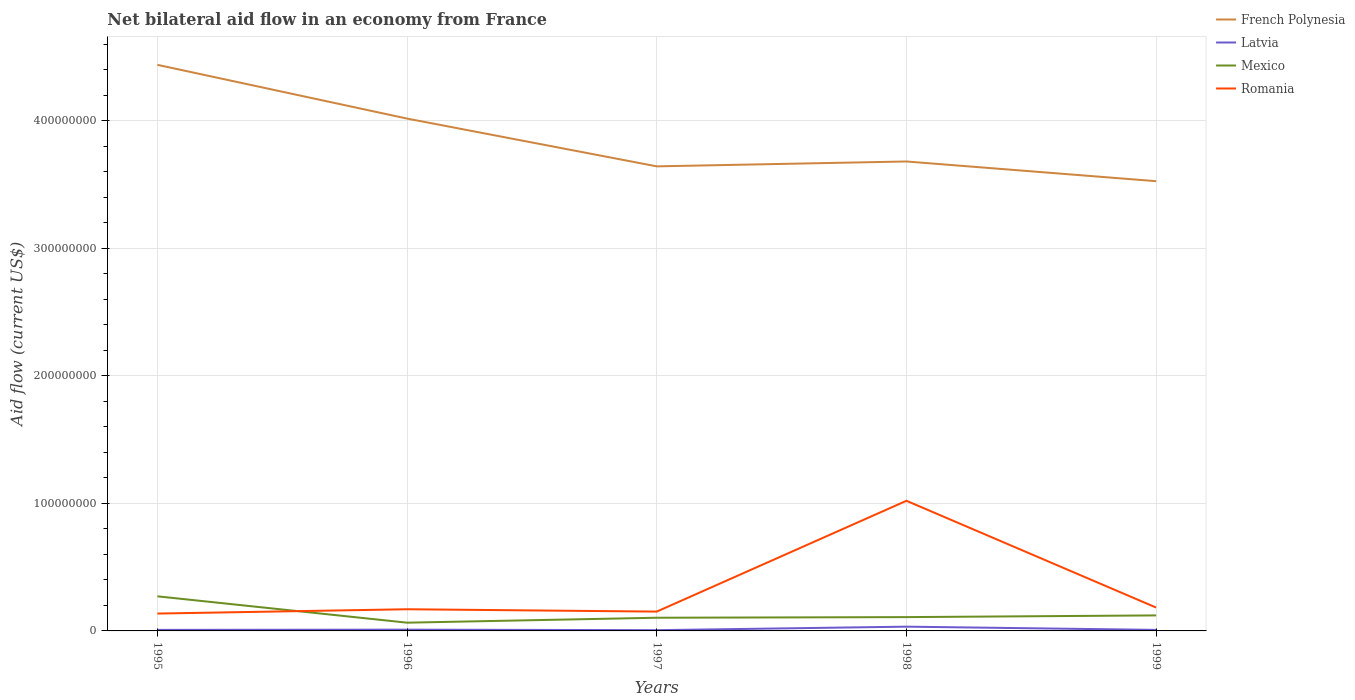How many different coloured lines are there?
Keep it short and to the point. 4. Across all years, what is the maximum net bilateral aid flow in Romania?
Offer a terse response. 1.36e+07. What is the total net bilateral aid flow in Latvia in the graph?
Provide a short and direct response. -2.52e+06. What is the difference between the highest and the second highest net bilateral aid flow in Mexico?
Give a very brief answer. 2.07e+07. What is the difference between the highest and the lowest net bilateral aid flow in Mexico?
Make the answer very short. 1. How many lines are there?
Provide a short and direct response. 4. What is the difference between two consecutive major ticks on the Y-axis?
Offer a terse response. 1.00e+08. Are the values on the major ticks of Y-axis written in scientific E-notation?
Keep it short and to the point. No. Does the graph contain grids?
Your answer should be compact. Yes. Where does the legend appear in the graph?
Keep it short and to the point. Top right. How many legend labels are there?
Your response must be concise. 4. How are the legend labels stacked?
Offer a terse response. Vertical. What is the title of the graph?
Ensure brevity in your answer.  Net bilateral aid flow in an economy from France. Does "Canada" appear as one of the legend labels in the graph?
Ensure brevity in your answer.  No. What is the Aid flow (current US$) of French Polynesia in 1995?
Your answer should be compact. 4.44e+08. What is the Aid flow (current US$) in Latvia in 1995?
Provide a succinct answer. 8.20e+05. What is the Aid flow (current US$) in Mexico in 1995?
Ensure brevity in your answer.  2.71e+07. What is the Aid flow (current US$) of Romania in 1995?
Keep it short and to the point. 1.36e+07. What is the Aid flow (current US$) in French Polynesia in 1996?
Keep it short and to the point. 4.02e+08. What is the Aid flow (current US$) in Latvia in 1996?
Offer a very short reply. 1.00e+06. What is the Aid flow (current US$) of Mexico in 1996?
Your response must be concise. 6.47e+06. What is the Aid flow (current US$) of Romania in 1996?
Offer a terse response. 1.70e+07. What is the Aid flow (current US$) in French Polynesia in 1997?
Your answer should be compact. 3.64e+08. What is the Aid flow (current US$) in Latvia in 1997?
Ensure brevity in your answer.  5.90e+05. What is the Aid flow (current US$) of Mexico in 1997?
Provide a succinct answer. 1.03e+07. What is the Aid flow (current US$) of Romania in 1997?
Offer a very short reply. 1.52e+07. What is the Aid flow (current US$) in French Polynesia in 1998?
Keep it short and to the point. 3.68e+08. What is the Aid flow (current US$) of Latvia in 1998?
Your answer should be very brief. 3.34e+06. What is the Aid flow (current US$) of Mexico in 1998?
Make the answer very short. 1.08e+07. What is the Aid flow (current US$) of Romania in 1998?
Keep it short and to the point. 1.02e+08. What is the Aid flow (current US$) in French Polynesia in 1999?
Offer a very short reply. 3.53e+08. What is the Aid flow (current US$) in Latvia in 1999?
Provide a short and direct response. 8.10e+05. What is the Aid flow (current US$) of Mexico in 1999?
Provide a succinct answer. 1.22e+07. What is the Aid flow (current US$) in Romania in 1999?
Provide a short and direct response. 1.83e+07. Across all years, what is the maximum Aid flow (current US$) of French Polynesia?
Make the answer very short. 4.44e+08. Across all years, what is the maximum Aid flow (current US$) in Latvia?
Ensure brevity in your answer.  3.34e+06. Across all years, what is the maximum Aid flow (current US$) in Mexico?
Give a very brief answer. 2.71e+07. Across all years, what is the maximum Aid flow (current US$) of Romania?
Provide a succinct answer. 1.02e+08. Across all years, what is the minimum Aid flow (current US$) in French Polynesia?
Ensure brevity in your answer.  3.53e+08. Across all years, what is the minimum Aid flow (current US$) in Latvia?
Give a very brief answer. 5.90e+05. Across all years, what is the minimum Aid flow (current US$) of Mexico?
Offer a very short reply. 6.47e+06. Across all years, what is the minimum Aid flow (current US$) of Romania?
Make the answer very short. 1.36e+07. What is the total Aid flow (current US$) of French Polynesia in the graph?
Ensure brevity in your answer.  1.93e+09. What is the total Aid flow (current US$) of Latvia in the graph?
Keep it short and to the point. 6.56e+06. What is the total Aid flow (current US$) of Mexico in the graph?
Provide a short and direct response. 6.69e+07. What is the total Aid flow (current US$) in Romania in the graph?
Your answer should be compact. 1.66e+08. What is the difference between the Aid flow (current US$) in French Polynesia in 1995 and that in 1996?
Make the answer very short. 4.22e+07. What is the difference between the Aid flow (current US$) in Latvia in 1995 and that in 1996?
Keep it short and to the point. -1.80e+05. What is the difference between the Aid flow (current US$) in Mexico in 1995 and that in 1996?
Your answer should be compact. 2.07e+07. What is the difference between the Aid flow (current US$) in Romania in 1995 and that in 1996?
Keep it short and to the point. -3.38e+06. What is the difference between the Aid flow (current US$) in French Polynesia in 1995 and that in 1997?
Keep it short and to the point. 7.96e+07. What is the difference between the Aid flow (current US$) of Mexico in 1995 and that in 1997?
Your answer should be very brief. 1.68e+07. What is the difference between the Aid flow (current US$) in Romania in 1995 and that in 1997?
Your response must be concise. -1.54e+06. What is the difference between the Aid flow (current US$) in French Polynesia in 1995 and that in 1998?
Offer a terse response. 7.58e+07. What is the difference between the Aid flow (current US$) of Latvia in 1995 and that in 1998?
Give a very brief answer. -2.52e+06. What is the difference between the Aid flow (current US$) of Mexico in 1995 and that in 1998?
Give a very brief answer. 1.63e+07. What is the difference between the Aid flow (current US$) of Romania in 1995 and that in 1998?
Offer a terse response. -8.84e+07. What is the difference between the Aid flow (current US$) in French Polynesia in 1995 and that in 1999?
Offer a terse response. 9.12e+07. What is the difference between the Aid flow (current US$) in Mexico in 1995 and that in 1999?
Make the answer very short. 1.50e+07. What is the difference between the Aid flow (current US$) of Romania in 1995 and that in 1999?
Give a very brief answer. -4.71e+06. What is the difference between the Aid flow (current US$) of French Polynesia in 1996 and that in 1997?
Your answer should be compact. 3.75e+07. What is the difference between the Aid flow (current US$) of Mexico in 1996 and that in 1997?
Make the answer very short. -3.87e+06. What is the difference between the Aid flow (current US$) in Romania in 1996 and that in 1997?
Provide a succinct answer. 1.84e+06. What is the difference between the Aid flow (current US$) of French Polynesia in 1996 and that in 1998?
Provide a succinct answer. 3.36e+07. What is the difference between the Aid flow (current US$) in Latvia in 1996 and that in 1998?
Your answer should be very brief. -2.34e+06. What is the difference between the Aid flow (current US$) in Mexico in 1996 and that in 1998?
Offer a terse response. -4.36e+06. What is the difference between the Aid flow (current US$) of Romania in 1996 and that in 1998?
Ensure brevity in your answer.  -8.51e+07. What is the difference between the Aid flow (current US$) in French Polynesia in 1996 and that in 1999?
Provide a short and direct response. 4.91e+07. What is the difference between the Aid flow (current US$) of Mexico in 1996 and that in 1999?
Keep it short and to the point. -5.70e+06. What is the difference between the Aid flow (current US$) in Romania in 1996 and that in 1999?
Provide a succinct answer. -1.33e+06. What is the difference between the Aid flow (current US$) of French Polynesia in 1997 and that in 1998?
Your answer should be very brief. -3.83e+06. What is the difference between the Aid flow (current US$) of Latvia in 1997 and that in 1998?
Your answer should be very brief. -2.75e+06. What is the difference between the Aid flow (current US$) in Mexico in 1997 and that in 1998?
Offer a terse response. -4.90e+05. What is the difference between the Aid flow (current US$) in Romania in 1997 and that in 1998?
Provide a succinct answer. -8.69e+07. What is the difference between the Aid flow (current US$) of French Polynesia in 1997 and that in 1999?
Your answer should be very brief. 1.16e+07. What is the difference between the Aid flow (current US$) of Mexico in 1997 and that in 1999?
Your answer should be compact. -1.83e+06. What is the difference between the Aid flow (current US$) of Romania in 1997 and that in 1999?
Provide a short and direct response. -3.17e+06. What is the difference between the Aid flow (current US$) of French Polynesia in 1998 and that in 1999?
Your answer should be compact. 1.55e+07. What is the difference between the Aid flow (current US$) of Latvia in 1998 and that in 1999?
Provide a short and direct response. 2.53e+06. What is the difference between the Aid flow (current US$) of Mexico in 1998 and that in 1999?
Offer a very short reply. -1.34e+06. What is the difference between the Aid flow (current US$) of Romania in 1998 and that in 1999?
Offer a terse response. 8.37e+07. What is the difference between the Aid flow (current US$) in French Polynesia in 1995 and the Aid flow (current US$) in Latvia in 1996?
Your answer should be compact. 4.43e+08. What is the difference between the Aid flow (current US$) of French Polynesia in 1995 and the Aid flow (current US$) of Mexico in 1996?
Ensure brevity in your answer.  4.38e+08. What is the difference between the Aid flow (current US$) of French Polynesia in 1995 and the Aid flow (current US$) of Romania in 1996?
Provide a short and direct response. 4.27e+08. What is the difference between the Aid flow (current US$) of Latvia in 1995 and the Aid flow (current US$) of Mexico in 1996?
Ensure brevity in your answer.  -5.65e+06. What is the difference between the Aid flow (current US$) of Latvia in 1995 and the Aid flow (current US$) of Romania in 1996?
Your answer should be compact. -1.62e+07. What is the difference between the Aid flow (current US$) of Mexico in 1995 and the Aid flow (current US$) of Romania in 1996?
Your answer should be very brief. 1.01e+07. What is the difference between the Aid flow (current US$) of French Polynesia in 1995 and the Aid flow (current US$) of Latvia in 1997?
Offer a terse response. 4.43e+08. What is the difference between the Aid flow (current US$) of French Polynesia in 1995 and the Aid flow (current US$) of Mexico in 1997?
Provide a succinct answer. 4.34e+08. What is the difference between the Aid flow (current US$) in French Polynesia in 1995 and the Aid flow (current US$) in Romania in 1997?
Your response must be concise. 4.29e+08. What is the difference between the Aid flow (current US$) of Latvia in 1995 and the Aid flow (current US$) of Mexico in 1997?
Provide a succinct answer. -9.52e+06. What is the difference between the Aid flow (current US$) in Latvia in 1995 and the Aid flow (current US$) in Romania in 1997?
Keep it short and to the point. -1.43e+07. What is the difference between the Aid flow (current US$) of Mexico in 1995 and the Aid flow (current US$) of Romania in 1997?
Your answer should be very brief. 1.20e+07. What is the difference between the Aid flow (current US$) of French Polynesia in 1995 and the Aid flow (current US$) of Latvia in 1998?
Make the answer very short. 4.41e+08. What is the difference between the Aid flow (current US$) of French Polynesia in 1995 and the Aid flow (current US$) of Mexico in 1998?
Offer a very short reply. 4.33e+08. What is the difference between the Aid flow (current US$) of French Polynesia in 1995 and the Aid flow (current US$) of Romania in 1998?
Your answer should be compact. 3.42e+08. What is the difference between the Aid flow (current US$) in Latvia in 1995 and the Aid flow (current US$) in Mexico in 1998?
Give a very brief answer. -1.00e+07. What is the difference between the Aid flow (current US$) of Latvia in 1995 and the Aid flow (current US$) of Romania in 1998?
Ensure brevity in your answer.  -1.01e+08. What is the difference between the Aid flow (current US$) in Mexico in 1995 and the Aid flow (current US$) in Romania in 1998?
Provide a short and direct response. -7.49e+07. What is the difference between the Aid flow (current US$) of French Polynesia in 1995 and the Aid flow (current US$) of Latvia in 1999?
Ensure brevity in your answer.  4.43e+08. What is the difference between the Aid flow (current US$) in French Polynesia in 1995 and the Aid flow (current US$) in Mexico in 1999?
Provide a succinct answer. 4.32e+08. What is the difference between the Aid flow (current US$) in French Polynesia in 1995 and the Aid flow (current US$) in Romania in 1999?
Your response must be concise. 4.26e+08. What is the difference between the Aid flow (current US$) of Latvia in 1995 and the Aid flow (current US$) of Mexico in 1999?
Ensure brevity in your answer.  -1.14e+07. What is the difference between the Aid flow (current US$) in Latvia in 1995 and the Aid flow (current US$) in Romania in 1999?
Your response must be concise. -1.75e+07. What is the difference between the Aid flow (current US$) of Mexico in 1995 and the Aid flow (current US$) of Romania in 1999?
Your response must be concise. 8.80e+06. What is the difference between the Aid flow (current US$) in French Polynesia in 1996 and the Aid flow (current US$) in Latvia in 1997?
Give a very brief answer. 4.01e+08. What is the difference between the Aid flow (current US$) of French Polynesia in 1996 and the Aid flow (current US$) of Mexico in 1997?
Your response must be concise. 3.91e+08. What is the difference between the Aid flow (current US$) of French Polynesia in 1996 and the Aid flow (current US$) of Romania in 1997?
Provide a short and direct response. 3.87e+08. What is the difference between the Aid flow (current US$) in Latvia in 1996 and the Aid flow (current US$) in Mexico in 1997?
Your response must be concise. -9.34e+06. What is the difference between the Aid flow (current US$) of Latvia in 1996 and the Aid flow (current US$) of Romania in 1997?
Keep it short and to the point. -1.42e+07. What is the difference between the Aid flow (current US$) in Mexico in 1996 and the Aid flow (current US$) in Romania in 1997?
Make the answer very short. -8.69e+06. What is the difference between the Aid flow (current US$) in French Polynesia in 1996 and the Aid flow (current US$) in Latvia in 1998?
Your answer should be compact. 3.98e+08. What is the difference between the Aid flow (current US$) in French Polynesia in 1996 and the Aid flow (current US$) in Mexico in 1998?
Make the answer very short. 3.91e+08. What is the difference between the Aid flow (current US$) in French Polynesia in 1996 and the Aid flow (current US$) in Romania in 1998?
Keep it short and to the point. 3.00e+08. What is the difference between the Aid flow (current US$) of Latvia in 1996 and the Aid flow (current US$) of Mexico in 1998?
Give a very brief answer. -9.83e+06. What is the difference between the Aid flow (current US$) of Latvia in 1996 and the Aid flow (current US$) of Romania in 1998?
Give a very brief answer. -1.01e+08. What is the difference between the Aid flow (current US$) in Mexico in 1996 and the Aid flow (current US$) in Romania in 1998?
Provide a short and direct response. -9.56e+07. What is the difference between the Aid flow (current US$) of French Polynesia in 1996 and the Aid flow (current US$) of Latvia in 1999?
Your response must be concise. 4.01e+08. What is the difference between the Aid flow (current US$) of French Polynesia in 1996 and the Aid flow (current US$) of Mexico in 1999?
Keep it short and to the point. 3.90e+08. What is the difference between the Aid flow (current US$) in French Polynesia in 1996 and the Aid flow (current US$) in Romania in 1999?
Ensure brevity in your answer.  3.83e+08. What is the difference between the Aid flow (current US$) of Latvia in 1996 and the Aid flow (current US$) of Mexico in 1999?
Give a very brief answer. -1.12e+07. What is the difference between the Aid flow (current US$) in Latvia in 1996 and the Aid flow (current US$) in Romania in 1999?
Your answer should be compact. -1.73e+07. What is the difference between the Aid flow (current US$) in Mexico in 1996 and the Aid flow (current US$) in Romania in 1999?
Your answer should be compact. -1.19e+07. What is the difference between the Aid flow (current US$) of French Polynesia in 1997 and the Aid flow (current US$) of Latvia in 1998?
Keep it short and to the point. 3.61e+08. What is the difference between the Aid flow (current US$) of French Polynesia in 1997 and the Aid flow (current US$) of Mexico in 1998?
Offer a terse response. 3.54e+08. What is the difference between the Aid flow (current US$) in French Polynesia in 1997 and the Aid flow (current US$) in Romania in 1998?
Provide a succinct answer. 2.62e+08. What is the difference between the Aid flow (current US$) in Latvia in 1997 and the Aid flow (current US$) in Mexico in 1998?
Your response must be concise. -1.02e+07. What is the difference between the Aid flow (current US$) of Latvia in 1997 and the Aid flow (current US$) of Romania in 1998?
Make the answer very short. -1.01e+08. What is the difference between the Aid flow (current US$) in Mexico in 1997 and the Aid flow (current US$) in Romania in 1998?
Provide a short and direct response. -9.17e+07. What is the difference between the Aid flow (current US$) in French Polynesia in 1997 and the Aid flow (current US$) in Latvia in 1999?
Your answer should be very brief. 3.64e+08. What is the difference between the Aid flow (current US$) of French Polynesia in 1997 and the Aid flow (current US$) of Mexico in 1999?
Your answer should be compact. 3.52e+08. What is the difference between the Aid flow (current US$) of French Polynesia in 1997 and the Aid flow (current US$) of Romania in 1999?
Ensure brevity in your answer.  3.46e+08. What is the difference between the Aid flow (current US$) in Latvia in 1997 and the Aid flow (current US$) in Mexico in 1999?
Your answer should be compact. -1.16e+07. What is the difference between the Aid flow (current US$) in Latvia in 1997 and the Aid flow (current US$) in Romania in 1999?
Your response must be concise. -1.77e+07. What is the difference between the Aid flow (current US$) in Mexico in 1997 and the Aid flow (current US$) in Romania in 1999?
Give a very brief answer. -7.99e+06. What is the difference between the Aid flow (current US$) in French Polynesia in 1998 and the Aid flow (current US$) in Latvia in 1999?
Make the answer very short. 3.67e+08. What is the difference between the Aid flow (current US$) of French Polynesia in 1998 and the Aid flow (current US$) of Mexico in 1999?
Keep it short and to the point. 3.56e+08. What is the difference between the Aid flow (current US$) of French Polynesia in 1998 and the Aid flow (current US$) of Romania in 1999?
Your response must be concise. 3.50e+08. What is the difference between the Aid flow (current US$) in Latvia in 1998 and the Aid flow (current US$) in Mexico in 1999?
Offer a terse response. -8.83e+06. What is the difference between the Aid flow (current US$) in Latvia in 1998 and the Aid flow (current US$) in Romania in 1999?
Make the answer very short. -1.50e+07. What is the difference between the Aid flow (current US$) in Mexico in 1998 and the Aid flow (current US$) in Romania in 1999?
Provide a short and direct response. -7.50e+06. What is the average Aid flow (current US$) in French Polynesia per year?
Make the answer very short. 3.86e+08. What is the average Aid flow (current US$) in Latvia per year?
Ensure brevity in your answer.  1.31e+06. What is the average Aid flow (current US$) in Mexico per year?
Give a very brief answer. 1.34e+07. What is the average Aid flow (current US$) in Romania per year?
Your answer should be very brief. 3.32e+07. In the year 1995, what is the difference between the Aid flow (current US$) of French Polynesia and Aid flow (current US$) of Latvia?
Provide a succinct answer. 4.43e+08. In the year 1995, what is the difference between the Aid flow (current US$) in French Polynesia and Aid flow (current US$) in Mexico?
Your answer should be compact. 4.17e+08. In the year 1995, what is the difference between the Aid flow (current US$) of French Polynesia and Aid flow (current US$) of Romania?
Ensure brevity in your answer.  4.30e+08. In the year 1995, what is the difference between the Aid flow (current US$) of Latvia and Aid flow (current US$) of Mexico?
Provide a succinct answer. -2.63e+07. In the year 1995, what is the difference between the Aid flow (current US$) in Latvia and Aid flow (current US$) in Romania?
Your answer should be very brief. -1.28e+07. In the year 1995, what is the difference between the Aid flow (current US$) in Mexico and Aid flow (current US$) in Romania?
Provide a succinct answer. 1.35e+07. In the year 1996, what is the difference between the Aid flow (current US$) of French Polynesia and Aid flow (current US$) of Latvia?
Provide a short and direct response. 4.01e+08. In the year 1996, what is the difference between the Aid flow (current US$) in French Polynesia and Aid flow (current US$) in Mexico?
Ensure brevity in your answer.  3.95e+08. In the year 1996, what is the difference between the Aid flow (current US$) in French Polynesia and Aid flow (current US$) in Romania?
Make the answer very short. 3.85e+08. In the year 1996, what is the difference between the Aid flow (current US$) in Latvia and Aid flow (current US$) in Mexico?
Keep it short and to the point. -5.47e+06. In the year 1996, what is the difference between the Aid flow (current US$) of Latvia and Aid flow (current US$) of Romania?
Keep it short and to the point. -1.60e+07. In the year 1996, what is the difference between the Aid flow (current US$) in Mexico and Aid flow (current US$) in Romania?
Your response must be concise. -1.05e+07. In the year 1997, what is the difference between the Aid flow (current US$) in French Polynesia and Aid flow (current US$) in Latvia?
Offer a very short reply. 3.64e+08. In the year 1997, what is the difference between the Aid flow (current US$) of French Polynesia and Aid flow (current US$) of Mexico?
Offer a terse response. 3.54e+08. In the year 1997, what is the difference between the Aid flow (current US$) in French Polynesia and Aid flow (current US$) in Romania?
Your answer should be very brief. 3.49e+08. In the year 1997, what is the difference between the Aid flow (current US$) of Latvia and Aid flow (current US$) of Mexico?
Your response must be concise. -9.75e+06. In the year 1997, what is the difference between the Aid flow (current US$) of Latvia and Aid flow (current US$) of Romania?
Provide a succinct answer. -1.46e+07. In the year 1997, what is the difference between the Aid flow (current US$) in Mexico and Aid flow (current US$) in Romania?
Provide a succinct answer. -4.82e+06. In the year 1998, what is the difference between the Aid flow (current US$) in French Polynesia and Aid flow (current US$) in Latvia?
Give a very brief answer. 3.65e+08. In the year 1998, what is the difference between the Aid flow (current US$) of French Polynesia and Aid flow (current US$) of Mexico?
Keep it short and to the point. 3.57e+08. In the year 1998, what is the difference between the Aid flow (current US$) in French Polynesia and Aid flow (current US$) in Romania?
Your answer should be compact. 2.66e+08. In the year 1998, what is the difference between the Aid flow (current US$) of Latvia and Aid flow (current US$) of Mexico?
Offer a terse response. -7.49e+06. In the year 1998, what is the difference between the Aid flow (current US$) in Latvia and Aid flow (current US$) in Romania?
Keep it short and to the point. -9.87e+07. In the year 1998, what is the difference between the Aid flow (current US$) of Mexico and Aid flow (current US$) of Romania?
Offer a very short reply. -9.12e+07. In the year 1999, what is the difference between the Aid flow (current US$) of French Polynesia and Aid flow (current US$) of Latvia?
Offer a very short reply. 3.52e+08. In the year 1999, what is the difference between the Aid flow (current US$) in French Polynesia and Aid flow (current US$) in Mexico?
Keep it short and to the point. 3.41e+08. In the year 1999, what is the difference between the Aid flow (current US$) of French Polynesia and Aid flow (current US$) of Romania?
Give a very brief answer. 3.34e+08. In the year 1999, what is the difference between the Aid flow (current US$) of Latvia and Aid flow (current US$) of Mexico?
Your answer should be compact. -1.14e+07. In the year 1999, what is the difference between the Aid flow (current US$) of Latvia and Aid flow (current US$) of Romania?
Offer a terse response. -1.75e+07. In the year 1999, what is the difference between the Aid flow (current US$) of Mexico and Aid flow (current US$) of Romania?
Provide a short and direct response. -6.16e+06. What is the ratio of the Aid flow (current US$) in French Polynesia in 1995 to that in 1996?
Make the answer very short. 1.1. What is the ratio of the Aid flow (current US$) in Latvia in 1995 to that in 1996?
Keep it short and to the point. 0.82. What is the ratio of the Aid flow (current US$) of Mexico in 1995 to that in 1996?
Offer a terse response. 4.19. What is the ratio of the Aid flow (current US$) of Romania in 1995 to that in 1996?
Your answer should be compact. 0.8. What is the ratio of the Aid flow (current US$) in French Polynesia in 1995 to that in 1997?
Your answer should be compact. 1.22. What is the ratio of the Aid flow (current US$) in Latvia in 1995 to that in 1997?
Offer a very short reply. 1.39. What is the ratio of the Aid flow (current US$) in Mexico in 1995 to that in 1997?
Provide a succinct answer. 2.62. What is the ratio of the Aid flow (current US$) in Romania in 1995 to that in 1997?
Provide a succinct answer. 0.9. What is the ratio of the Aid flow (current US$) in French Polynesia in 1995 to that in 1998?
Your answer should be very brief. 1.21. What is the ratio of the Aid flow (current US$) of Latvia in 1995 to that in 1998?
Offer a terse response. 0.25. What is the ratio of the Aid flow (current US$) of Mexico in 1995 to that in 1998?
Your response must be concise. 2.51. What is the ratio of the Aid flow (current US$) of Romania in 1995 to that in 1998?
Your answer should be compact. 0.13. What is the ratio of the Aid flow (current US$) in French Polynesia in 1995 to that in 1999?
Your answer should be compact. 1.26. What is the ratio of the Aid flow (current US$) of Latvia in 1995 to that in 1999?
Provide a succinct answer. 1.01. What is the ratio of the Aid flow (current US$) in Mexico in 1995 to that in 1999?
Your response must be concise. 2.23. What is the ratio of the Aid flow (current US$) of Romania in 1995 to that in 1999?
Offer a terse response. 0.74. What is the ratio of the Aid flow (current US$) of French Polynesia in 1996 to that in 1997?
Offer a very short reply. 1.1. What is the ratio of the Aid flow (current US$) in Latvia in 1996 to that in 1997?
Your answer should be very brief. 1.69. What is the ratio of the Aid flow (current US$) in Mexico in 1996 to that in 1997?
Your answer should be very brief. 0.63. What is the ratio of the Aid flow (current US$) in Romania in 1996 to that in 1997?
Ensure brevity in your answer.  1.12. What is the ratio of the Aid flow (current US$) of French Polynesia in 1996 to that in 1998?
Offer a very short reply. 1.09. What is the ratio of the Aid flow (current US$) of Latvia in 1996 to that in 1998?
Keep it short and to the point. 0.3. What is the ratio of the Aid flow (current US$) in Mexico in 1996 to that in 1998?
Make the answer very short. 0.6. What is the ratio of the Aid flow (current US$) in Romania in 1996 to that in 1998?
Offer a very short reply. 0.17. What is the ratio of the Aid flow (current US$) of French Polynesia in 1996 to that in 1999?
Your answer should be compact. 1.14. What is the ratio of the Aid flow (current US$) in Latvia in 1996 to that in 1999?
Provide a short and direct response. 1.23. What is the ratio of the Aid flow (current US$) in Mexico in 1996 to that in 1999?
Make the answer very short. 0.53. What is the ratio of the Aid flow (current US$) of Romania in 1996 to that in 1999?
Give a very brief answer. 0.93. What is the ratio of the Aid flow (current US$) in Latvia in 1997 to that in 1998?
Ensure brevity in your answer.  0.18. What is the ratio of the Aid flow (current US$) of Mexico in 1997 to that in 1998?
Ensure brevity in your answer.  0.95. What is the ratio of the Aid flow (current US$) in Romania in 1997 to that in 1998?
Offer a terse response. 0.15. What is the ratio of the Aid flow (current US$) of French Polynesia in 1997 to that in 1999?
Keep it short and to the point. 1.03. What is the ratio of the Aid flow (current US$) in Latvia in 1997 to that in 1999?
Offer a terse response. 0.73. What is the ratio of the Aid flow (current US$) of Mexico in 1997 to that in 1999?
Provide a succinct answer. 0.85. What is the ratio of the Aid flow (current US$) of Romania in 1997 to that in 1999?
Keep it short and to the point. 0.83. What is the ratio of the Aid flow (current US$) of French Polynesia in 1998 to that in 1999?
Ensure brevity in your answer.  1.04. What is the ratio of the Aid flow (current US$) of Latvia in 1998 to that in 1999?
Give a very brief answer. 4.12. What is the ratio of the Aid flow (current US$) of Mexico in 1998 to that in 1999?
Offer a terse response. 0.89. What is the ratio of the Aid flow (current US$) of Romania in 1998 to that in 1999?
Your answer should be very brief. 5.57. What is the difference between the highest and the second highest Aid flow (current US$) of French Polynesia?
Keep it short and to the point. 4.22e+07. What is the difference between the highest and the second highest Aid flow (current US$) of Latvia?
Ensure brevity in your answer.  2.34e+06. What is the difference between the highest and the second highest Aid flow (current US$) in Mexico?
Give a very brief answer. 1.50e+07. What is the difference between the highest and the second highest Aid flow (current US$) of Romania?
Provide a succinct answer. 8.37e+07. What is the difference between the highest and the lowest Aid flow (current US$) of French Polynesia?
Offer a very short reply. 9.12e+07. What is the difference between the highest and the lowest Aid flow (current US$) of Latvia?
Your response must be concise. 2.75e+06. What is the difference between the highest and the lowest Aid flow (current US$) of Mexico?
Provide a short and direct response. 2.07e+07. What is the difference between the highest and the lowest Aid flow (current US$) of Romania?
Keep it short and to the point. 8.84e+07. 